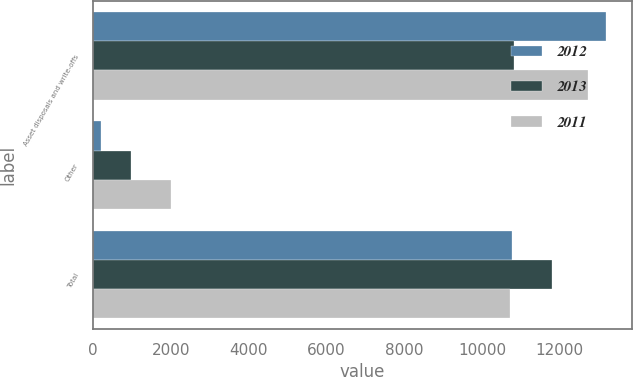Convert chart to OTSL. <chart><loc_0><loc_0><loc_500><loc_500><stacked_bar_chart><ecel><fcel>Asset disposals and write-offs<fcel>Other<fcel>Total<nl><fcel>2012<fcel>13192<fcel>208<fcel>10772<nl><fcel>2013<fcel>10821<fcel>968<fcel>11789<nl><fcel>2011<fcel>12726<fcel>2003<fcel>10723<nl></chart> 